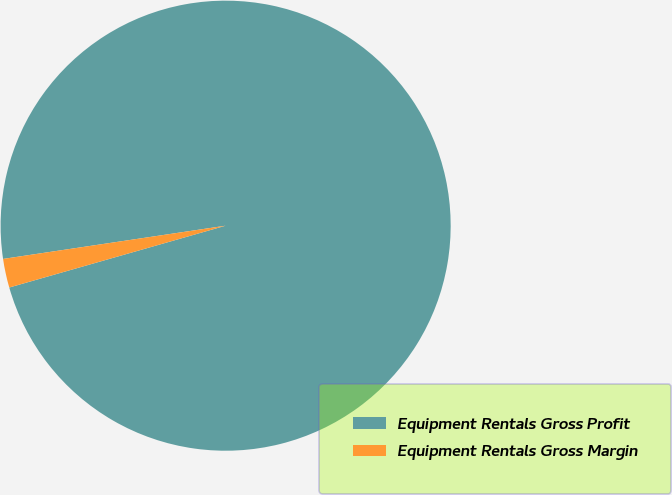Convert chart. <chart><loc_0><loc_0><loc_500><loc_500><pie_chart><fcel>Equipment Rentals Gross Profit<fcel>Equipment Rentals Gross Margin<nl><fcel>97.93%<fcel>2.07%<nl></chart> 